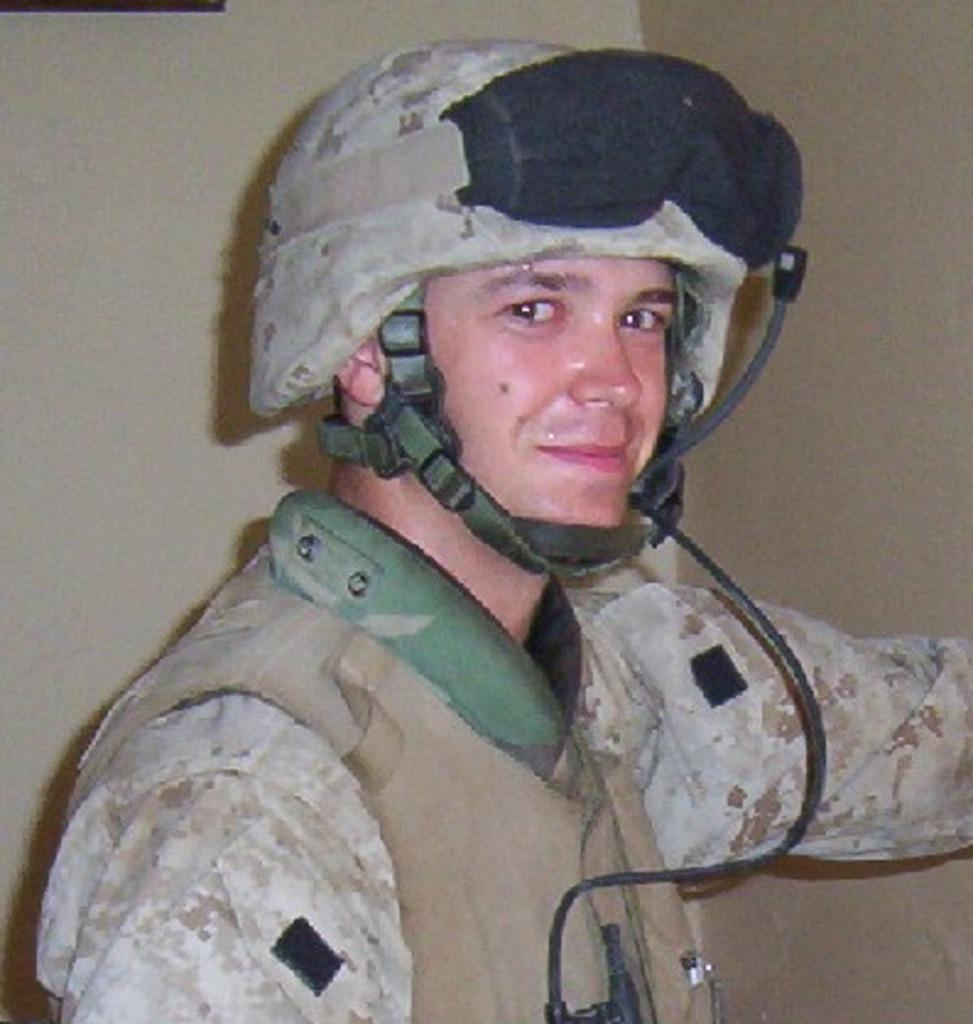What is the main subject in the foreground of the image? There is a man in the foreground of the image. What is the man wearing on his upper body? The man is wearing a jacket. What type of headgear is the man wearing? The man is wearing a helmet. What can be seen in the background of the image? There is a wall in the background of the image. What type of meat is the man holding in the image? There is no meat present in the image; the man is wearing a jacket and helmet. How many babies are visible in the image? There are no babies present in the image; it features a man wearing a jacket and helmet with a wall in the background. 